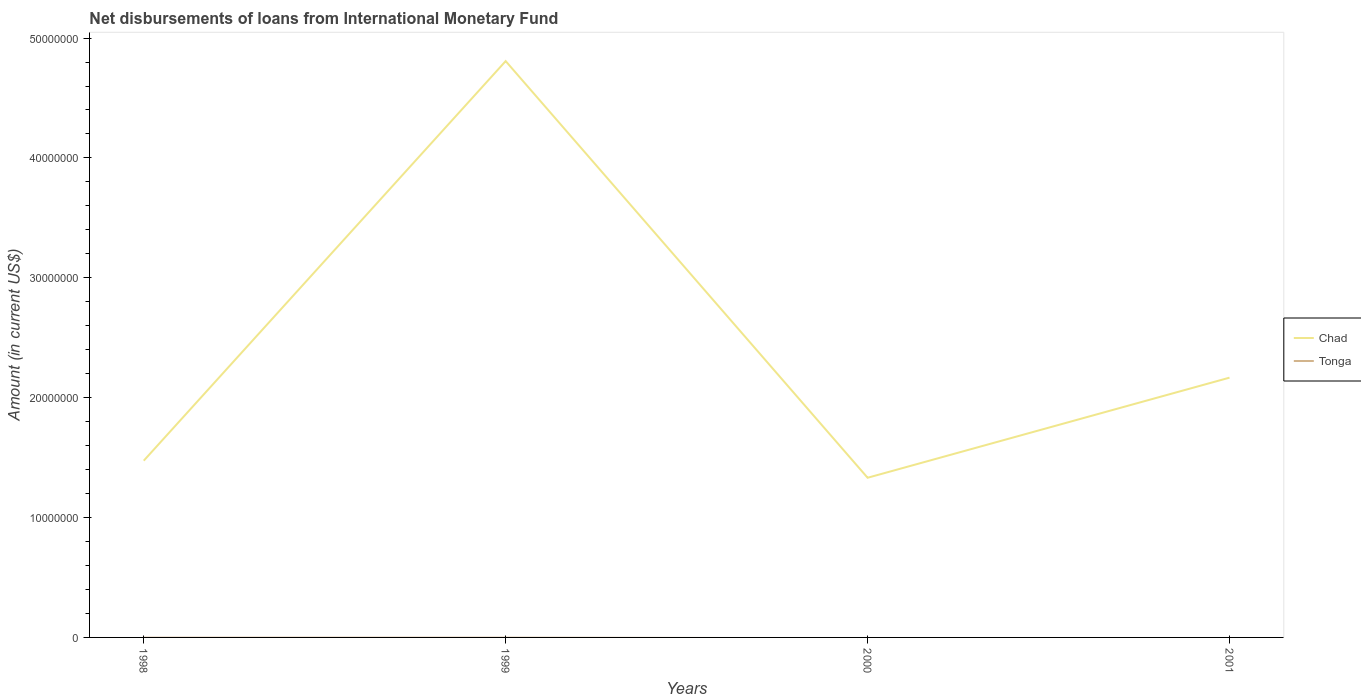How many different coloured lines are there?
Provide a succinct answer. 1. Across all years, what is the maximum amount of loans disbursed in Chad?
Keep it short and to the point. 1.33e+07. What is the total amount of loans disbursed in Chad in the graph?
Provide a short and direct response. 2.64e+07. What is the difference between the highest and the second highest amount of loans disbursed in Chad?
Your answer should be compact. 3.48e+07. What is the difference between two consecutive major ticks on the Y-axis?
Offer a terse response. 1.00e+07. Are the values on the major ticks of Y-axis written in scientific E-notation?
Your answer should be compact. No. Does the graph contain grids?
Offer a very short reply. No. Where does the legend appear in the graph?
Offer a terse response. Center right. How are the legend labels stacked?
Keep it short and to the point. Vertical. What is the title of the graph?
Your answer should be very brief. Net disbursements of loans from International Monetary Fund. What is the Amount (in current US$) of Chad in 1998?
Offer a terse response. 1.47e+07. What is the Amount (in current US$) in Tonga in 1998?
Provide a short and direct response. 0. What is the Amount (in current US$) of Chad in 1999?
Give a very brief answer. 4.81e+07. What is the Amount (in current US$) of Chad in 2000?
Offer a very short reply. 1.33e+07. What is the Amount (in current US$) of Chad in 2001?
Your answer should be very brief. 2.17e+07. What is the Amount (in current US$) of Tonga in 2001?
Offer a terse response. 0. Across all years, what is the maximum Amount (in current US$) of Chad?
Your response must be concise. 4.81e+07. Across all years, what is the minimum Amount (in current US$) of Chad?
Your response must be concise. 1.33e+07. What is the total Amount (in current US$) of Chad in the graph?
Your response must be concise. 9.78e+07. What is the total Amount (in current US$) of Tonga in the graph?
Make the answer very short. 0. What is the difference between the Amount (in current US$) of Chad in 1998 and that in 1999?
Offer a terse response. -3.33e+07. What is the difference between the Amount (in current US$) of Chad in 1998 and that in 2000?
Ensure brevity in your answer.  1.42e+06. What is the difference between the Amount (in current US$) in Chad in 1998 and that in 2001?
Provide a succinct answer. -6.93e+06. What is the difference between the Amount (in current US$) of Chad in 1999 and that in 2000?
Offer a terse response. 3.48e+07. What is the difference between the Amount (in current US$) of Chad in 1999 and that in 2001?
Offer a very short reply. 2.64e+07. What is the difference between the Amount (in current US$) of Chad in 2000 and that in 2001?
Offer a terse response. -8.35e+06. What is the average Amount (in current US$) in Chad per year?
Your answer should be compact. 2.45e+07. What is the average Amount (in current US$) in Tonga per year?
Give a very brief answer. 0. What is the ratio of the Amount (in current US$) in Chad in 1998 to that in 1999?
Make the answer very short. 0.31. What is the ratio of the Amount (in current US$) of Chad in 1998 to that in 2000?
Your response must be concise. 1.11. What is the ratio of the Amount (in current US$) of Chad in 1998 to that in 2001?
Your response must be concise. 0.68. What is the ratio of the Amount (in current US$) in Chad in 1999 to that in 2000?
Your answer should be very brief. 3.61. What is the ratio of the Amount (in current US$) in Chad in 1999 to that in 2001?
Keep it short and to the point. 2.22. What is the ratio of the Amount (in current US$) in Chad in 2000 to that in 2001?
Provide a short and direct response. 0.61. What is the difference between the highest and the second highest Amount (in current US$) in Chad?
Provide a short and direct response. 2.64e+07. What is the difference between the highest and the lowest Amount (in current US$) in Chad?
Offer a very short reply. 3.48e+07. 